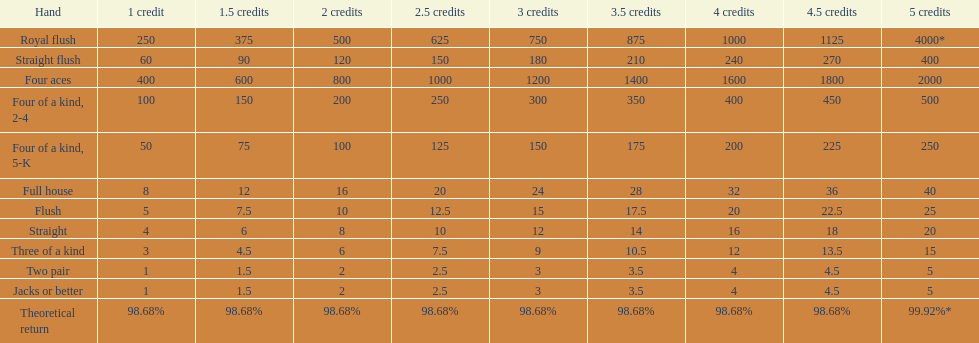What is the total amount of a 3 credit straight flush? 180. 